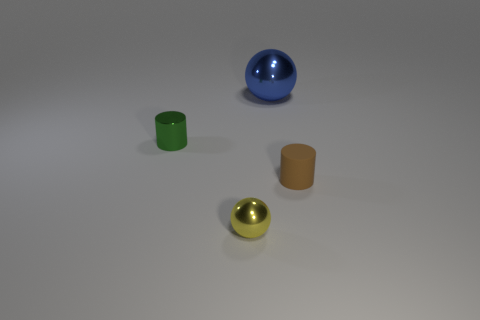There is a ball that is on the left side of the blue ball; is it the same size as the big sphere?
Give a very brief answer. No. Is the number of spheres to the right of the small rubber cylinder less than the number of large spheres on the right side of the big metal ball?
Your answer should be very brief. No. Is the metal cylinder the same color as the big sphere?
Keep it short and to the point. No. Is the number of yellow metallic things that are right of the large metal object less than the number of blue rubber cylinders?
Make the answer very short. No. Is the material of the big blue sphere the same as the small brown object?
Provide a short and direct response. No. What number of tiny green cylinders are the same material as the blue object?
Ensure brevity in your answer.  1. There is a big sphere that is the same material as the small yellow ball; what is its color?
Offer a terse response. Blue. The yellow metal object has what shape?
Give a very brief answer. Sphere. There is a big blue sphere on the right side of the green cylinder; what is its material?
Your answer should be compact. Metal. Is there a metallic cube of the same color as the large ball?
Your answer should be compact. No. 